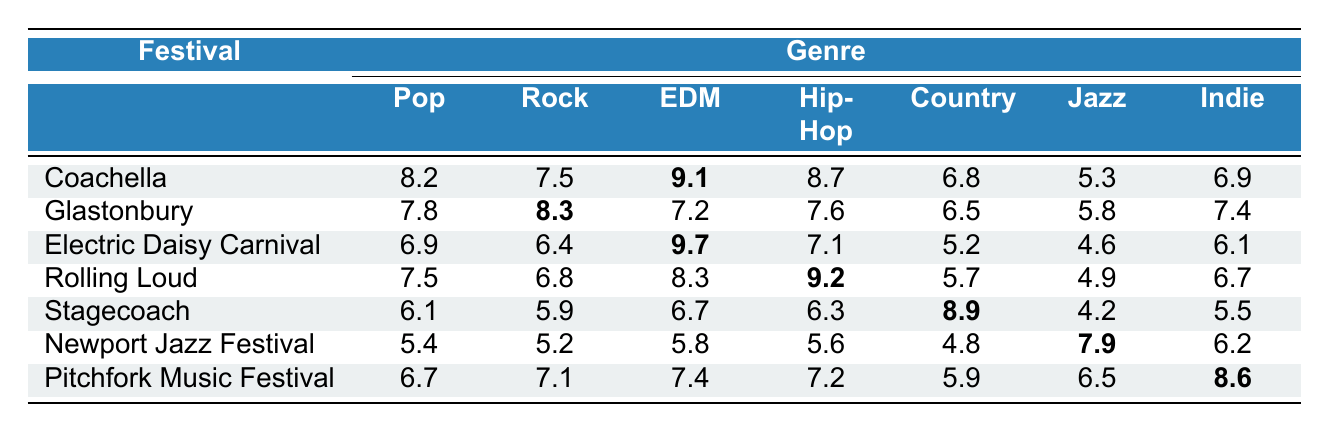What is the engagement rate for Pop music at Coachella? The table indicates the engagement rate for Pop music at Coachella is 8.2.
Answer: 8.2 Which genre has the highest engagement rate at the Electric Daisy Carnival? In the table, the engagement rates for Electric Daisy Carnival show that EDM has the highest rate at 9.7.
Answer: EDM What is the average engagement rate for Hip-Hop across all festivals? The engagement rates for Hip-Hop are 8.7, 7.6, 7.1, 9.2, 6.3, 5.6, and 7.2. Summing these gives 54.7, and dividing by 7 gives an average of 7.81.
Answer: 7.81 Is the engagement rate for Jazz at the Newport Jazz Festival higher than the engagement rate for Jazz at Pitchfork Music Festival? The rate for Jazz at Newport Jazz Festival is 7.9, while at Pitchfork Music Festival it is 6.5. Since 7.9 is greater than 6.5, the statement is true.
Answer: Yes Which festival has the least engagement rate for Country music? By examining the Country engagement rates of each festival, we see Stagecoach has the lowest rate at 4.2.
Answer: Stagecoach What is the difference in engagement rates for Pop music between Rolling Loud and Glastonbury? The Pop engagement rate for Rolling Loud is 7.5 and for Glastonbury is 7.8. The difference is calculated as 7.8 - 7.5 = 0.3.
Answer: 0.3 How many festivals have an engagement rate for Indie music that is higher than 7? The rates for Indie music are 6.9, 7.4, 6.1, 6.7, 5.5, 6.2, and 8.6. Only Pitchfork Music Festival has a rate above 7, making it 1 festival.
Answer: 1 Which genre has the highest overall engagement rate across all festivals? By analyzing the highest values in each genre's row, we see EDM at Electric Daisy Carnival has the top rate of 9.7.
Answer: EDM What is the median engagement rate for Rock music across the festivals? The Rock engagement rates are 7.5, 8.3, 6.4, 6.8, 5.9, 5.2, and 7.1. Arranging these rates in order gives 5.2, 5.9, 6.4, 6.8, 7.1, 7.5, 8.3. The median, the middle value, is 6.8.
Answer: 6.8 Is there any festival where Jazz engagement rate exceeds 6.5? Comparing the Jazz rates, Newport Jazz Festival at 7.9 and Pitchfork Music Festival at 8.6 both exceed 6.5, making the statement true.
Answer: Yes 